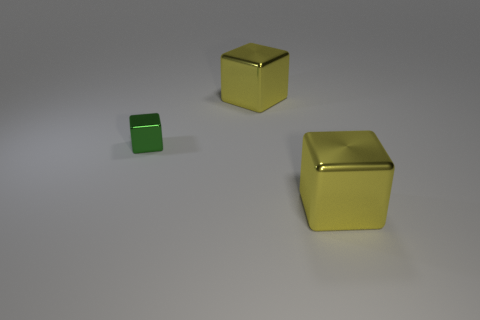The large metallic block in front of the big yellow cube that is behind the green metal cube is what color?
Your response must be concise. Yellow. Are there any other cubes that have the same color as the small block?
Keep it short and to the point. No. There is a yellow metal object right of the yellow shiny block behind the big shiny thing in front of the green object; what is its size?
Ensure brevity in your answer.  Large. What is the shape of the tiny metal thing?
Your answer should be very brief. Cube. There is a yellow cube in front of the tiny green shiny object; what number of big yellow shiny blocks are behind it?
Provide a succinct answer. 1. How many other objects are the same material as the tiny block?
Offer a very short reply. 2. Is the big yellow cube behind the small green cube made of the same material as the yellow object that is in front of the green block?
Ensure brevity in your answer.  Yes. Is there any other thing that is the same shape as the tiny green shiny thing?
Your response must be concise. Yes. What is the color of the metallic block on the right side of the big cube that is behind the big shiny block that is in front of the green block?
Provide a succinct answer. Yellow. Is there any other thing that has the same size as the green metallic cube?
Ensure brevity in your answer.  No. 